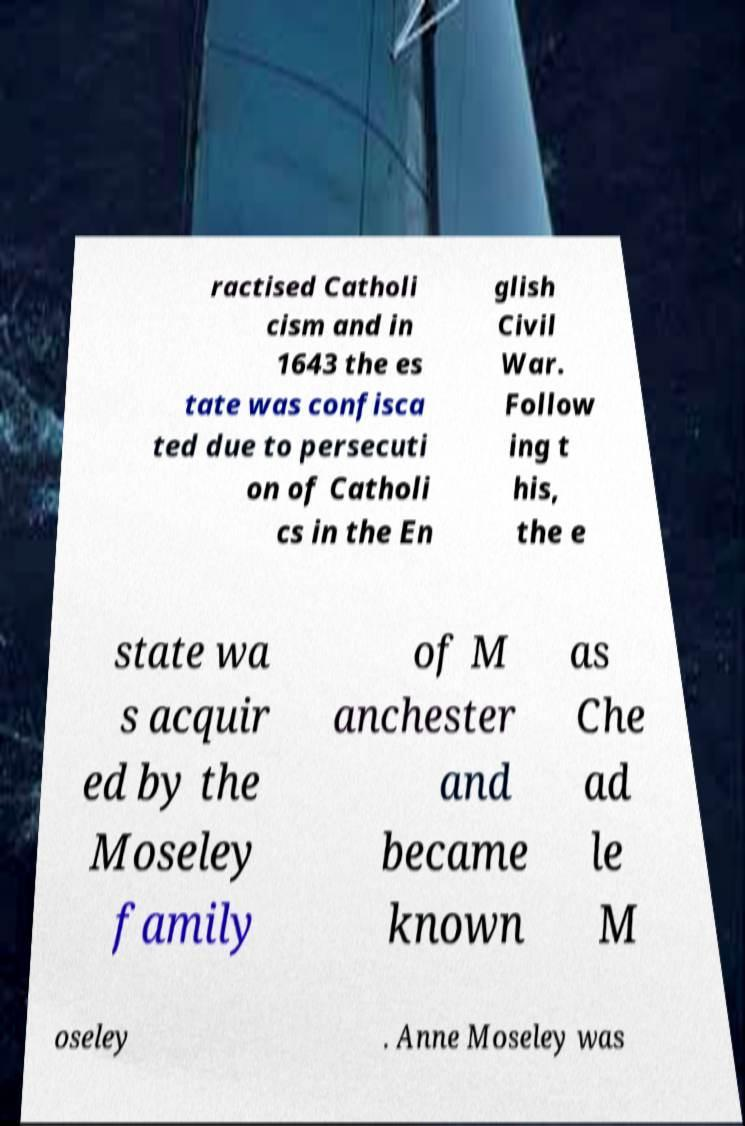For documentation purposes, I need the text within this image transcribed. Could you provide that? ractised Catholi cism and in 1643 the es tate was confisca ted due to persecuti on of Catholi cs in the En glish Civil War. Follow ing t his, the e state wa s acquir ed by the Moseley family of M anchester and became known as Che ad le M oseley . Anne Moseley was 